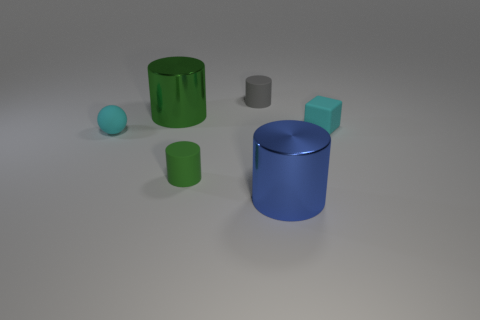Can you describe the size relationship between the blue cylinder and the green rubber cylinder? Certainly! The blue cylinder is the tallest object in the image, standing significantly higher than the green rubber cylinder, which is shorter and also narrower in diameter. 